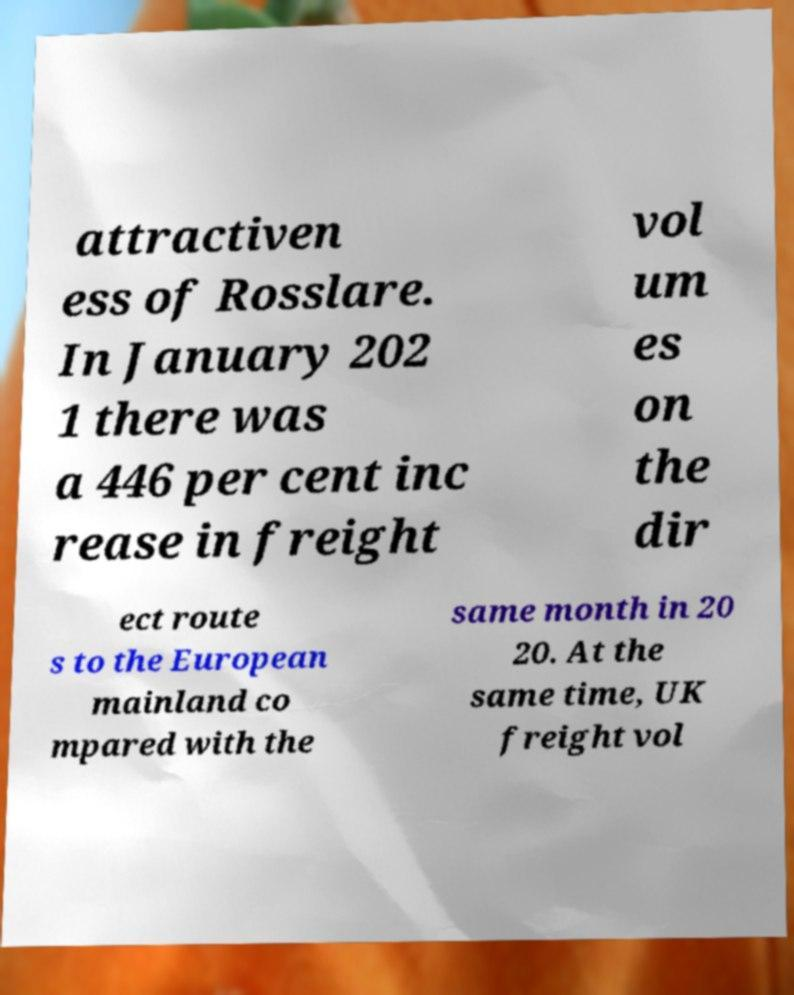There's text embedded in this image that I need extracted. Can you transcribe it verbatim? attractiven ess of Rosslare. In January 202 1 there was a 446 per cent inc rease in freight vol um es on the dir ect route s to the European mainland co mpared with the same month in 20 20. At the same time, UK freight vol 